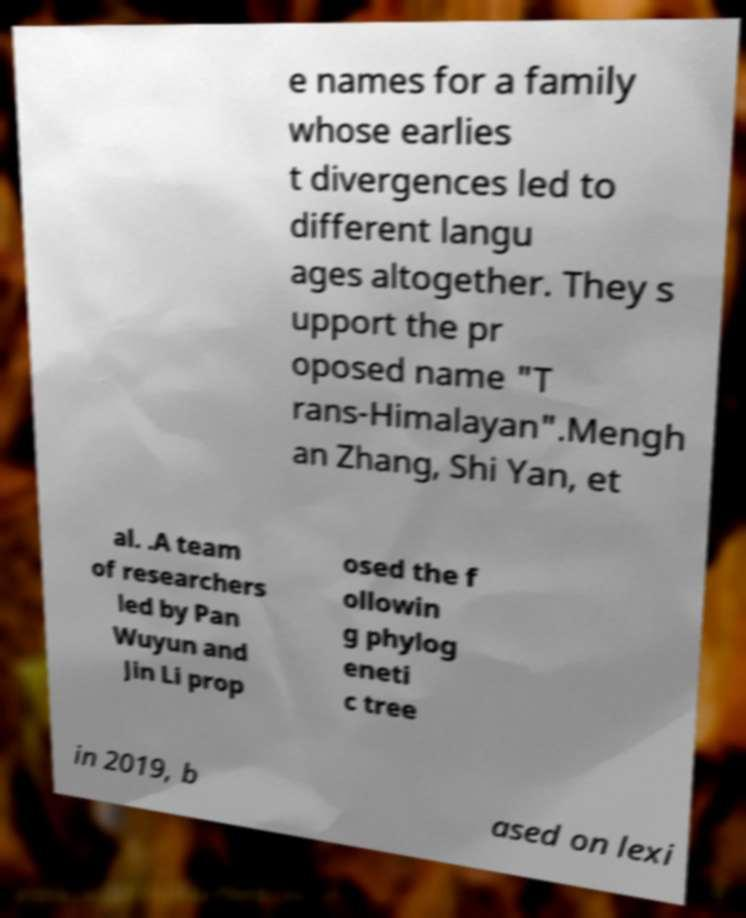For documentation purposes, I need the text within this image transcribed. Could you provide that? e names for a family whose earlies t divergences led to different langu ages altogether. They s upport the pr oposed name "T rans-Himalayan".Mengh an Zhang, Shi Yan, et al. .A team of researchers led by Pan Wuyun and Jin Li prop osed the f ollowin g phylog eneti c tree in 2019, b ased on lexi 